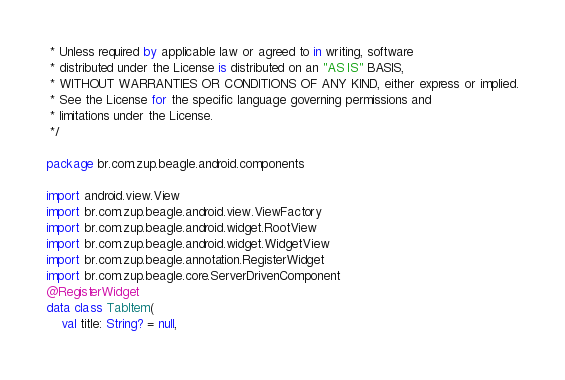<code> <loc_0><loc_0><loc_500><loc_500><_Kotlin_> * Unless required by applicable law or agreed to in writing, software
 * distributed under the License is distributed on an "AS IS" BASIS,
 * WITHOUT WARRANTIES OR CONDITIONS OF ANY KIND, either express or implied.
 * See the License for the specific language governing permissions and
 * limitations under the License.
 */

package br.com.zup.beagle.android.components

import android.view.View
import br.com.zup.beagle.android.view.ViewFactory
import br.com.zup.beagle.android.widget.RootView
import br.com.zup.beagle.android.widget.WidgetView
import br.com.zup.beagle.annotation.RegisterWidget
import br.com.zup.beagle.core.ServerDrivenComponent
@RegisterWidget
data class TabItem(
    val title: String? = null,</code> 